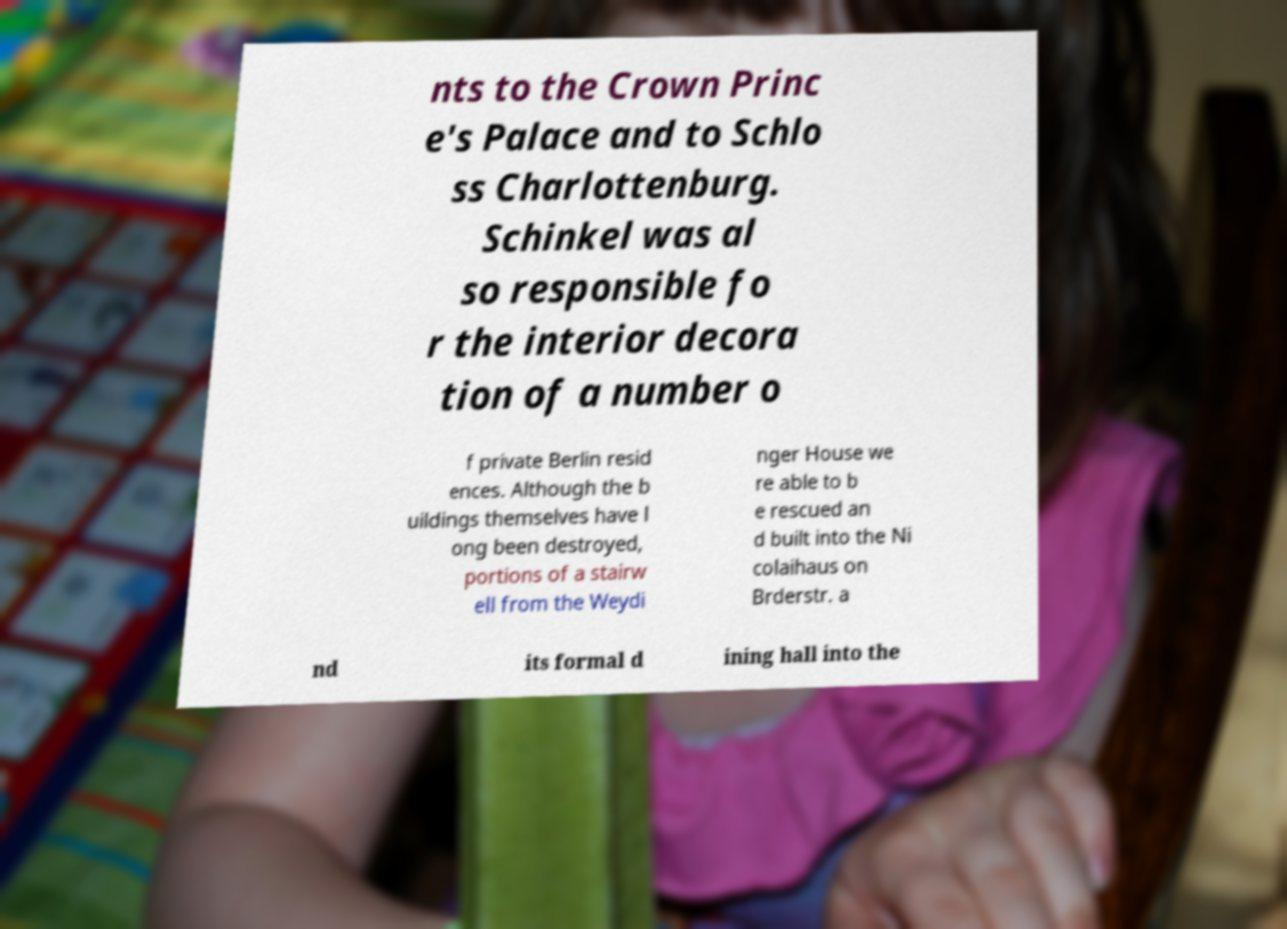Could you assist in decoding the text presented in this image and type it out clearly? nts to the Crown Princ e's Palace and to Schlo ss Charlottenburg. Schinkel was al so responsible fo r the interior decora tion of a number o f private Berlin resid ences. Although the b uildings themselves have l ong been destroyed, portions of a stairw ell from the Weydi nger House we re able to b e rescued an d built into the Ni colaihaus on Brderstr. a nd its formal d ining hall into the 